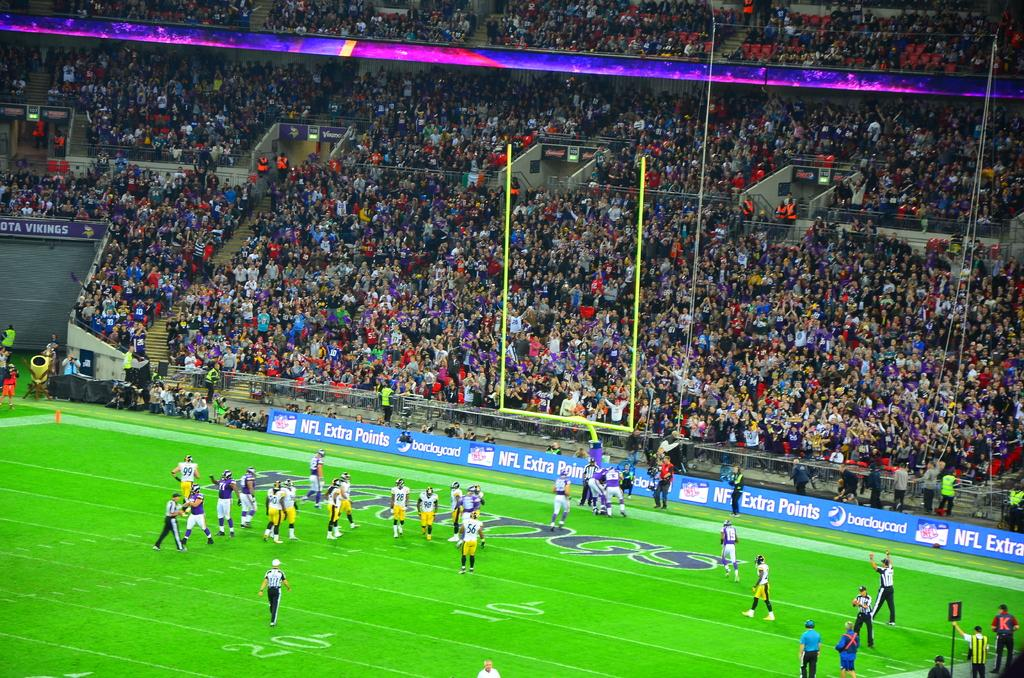<image>
Summarize the visual content of the image. a scene of an NFL football game with many fans in the stands and a blue sign reading NFL extra points 